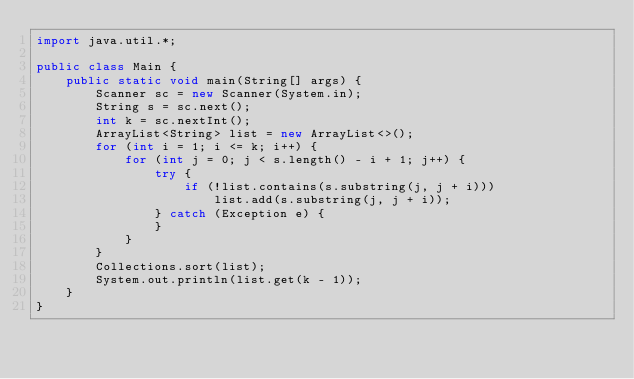Convert code to text. <code><loc_0><loc_0><loc_500><loc_500><_Java_>import java.util.*;

public class Main {
    public static void main(String[] args) {
        Scanner sc = new Scanner(System.in);
        String s = sc.next();
        int k = sc.nextInt();
        ArrayList<String> list = new ArrayList<>();
        for (int i = 1; i <= k; i++) {
            for (int j = 0; j < s.length() - i + 1; j++) {
                try {
                    if (!list.contains(s.substring(j, j + i)))
                        list.add(s.substring(j, j + i));
                } catch (Exception e) {
                }
            }
        }
        Collections.sort(list);
        System.out.println(list.get(k - 1));
    }
}
</code> 